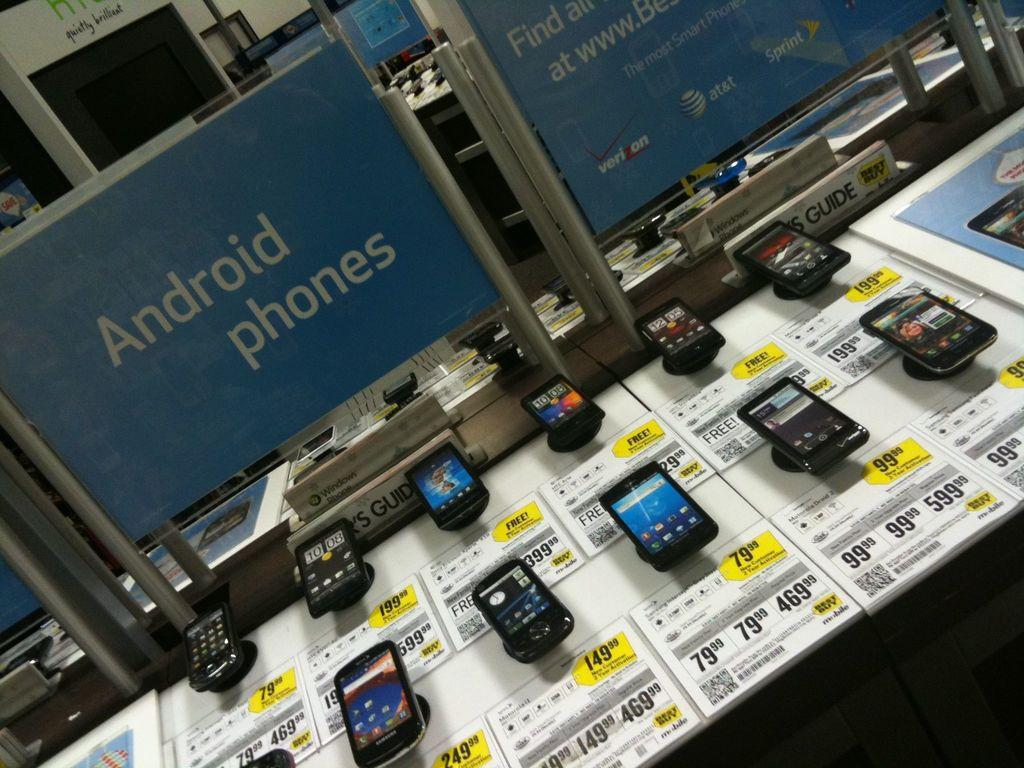<image>
Summarize the visual content of the image. Several phones are displayed, one of which is selling for 149.998 